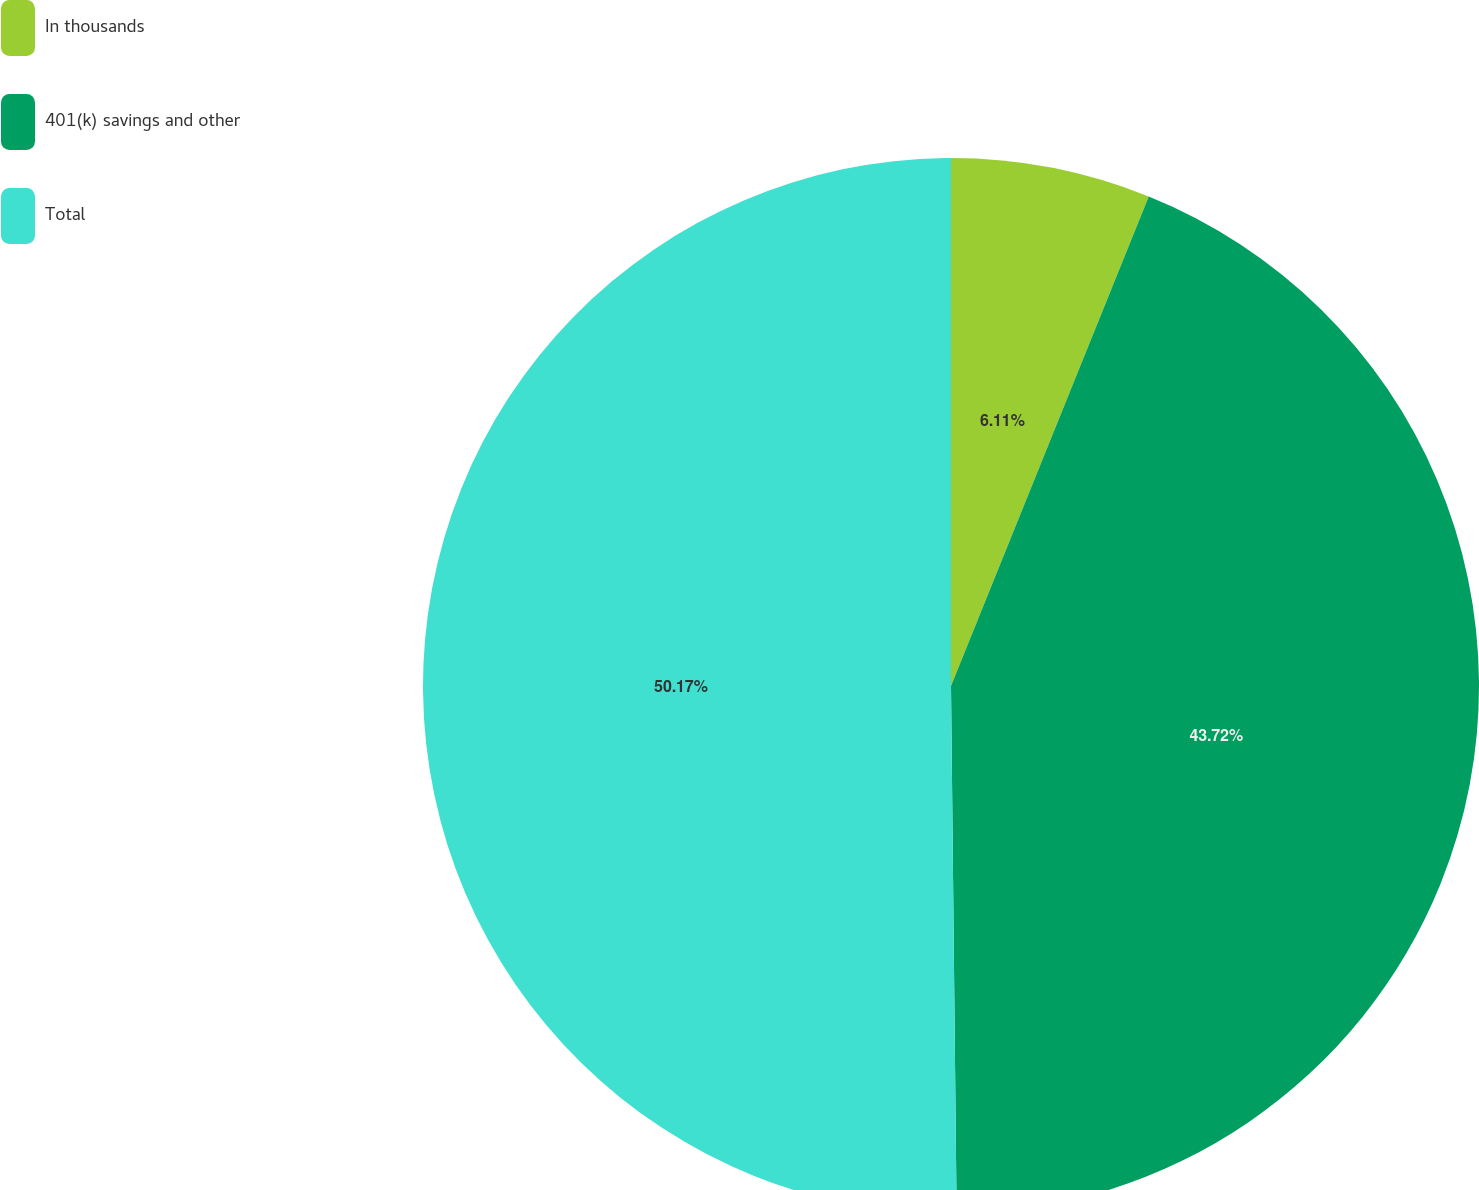Convert chart. <chart><loc_0><loc_0><loc_500><loc_500><pie_chart><fcel>In thousands<fcel>401(k) savings and other<fcel>Total<nl><fcel>6.11%<fcel>43.72%<fcel>50.17%<nl></chart> 